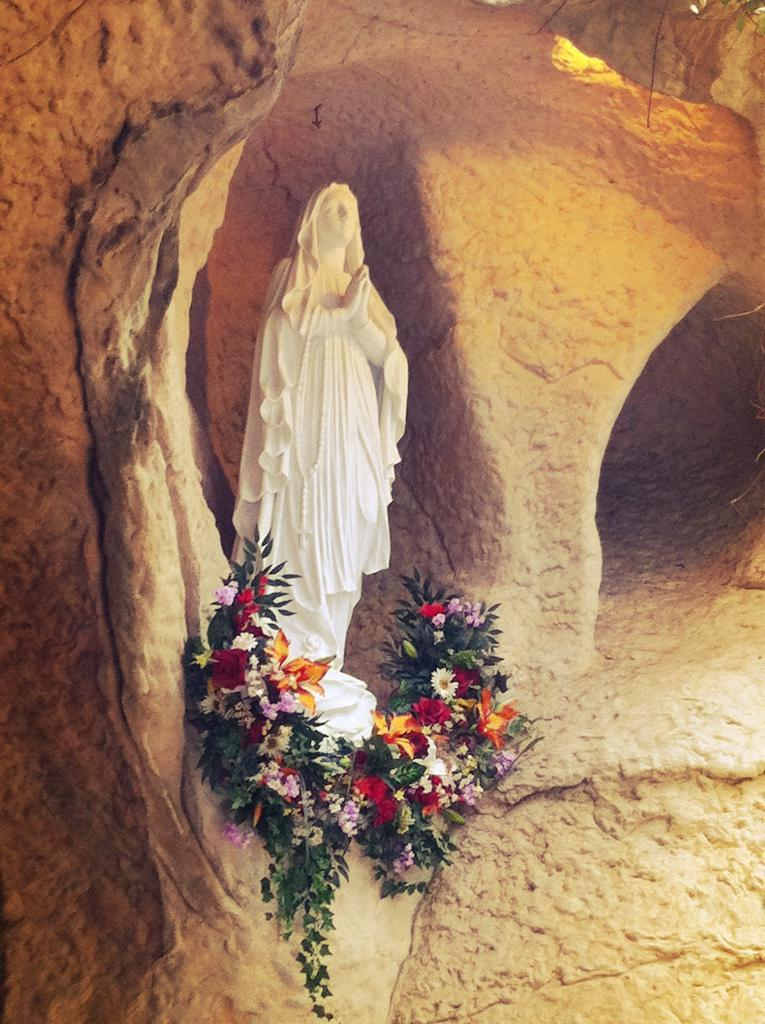What is the main subject in the image? There is a statue in the image. What else can be seen in the image besides the statue? There are flowers in the image. What type of sidewalk is visible in the image? There is no sidewalk present in the image; it only features a statue and flowers. Can you see a bat flying near the statue in the image? There is no bat visible in the image; it only features a statue and flowers. 